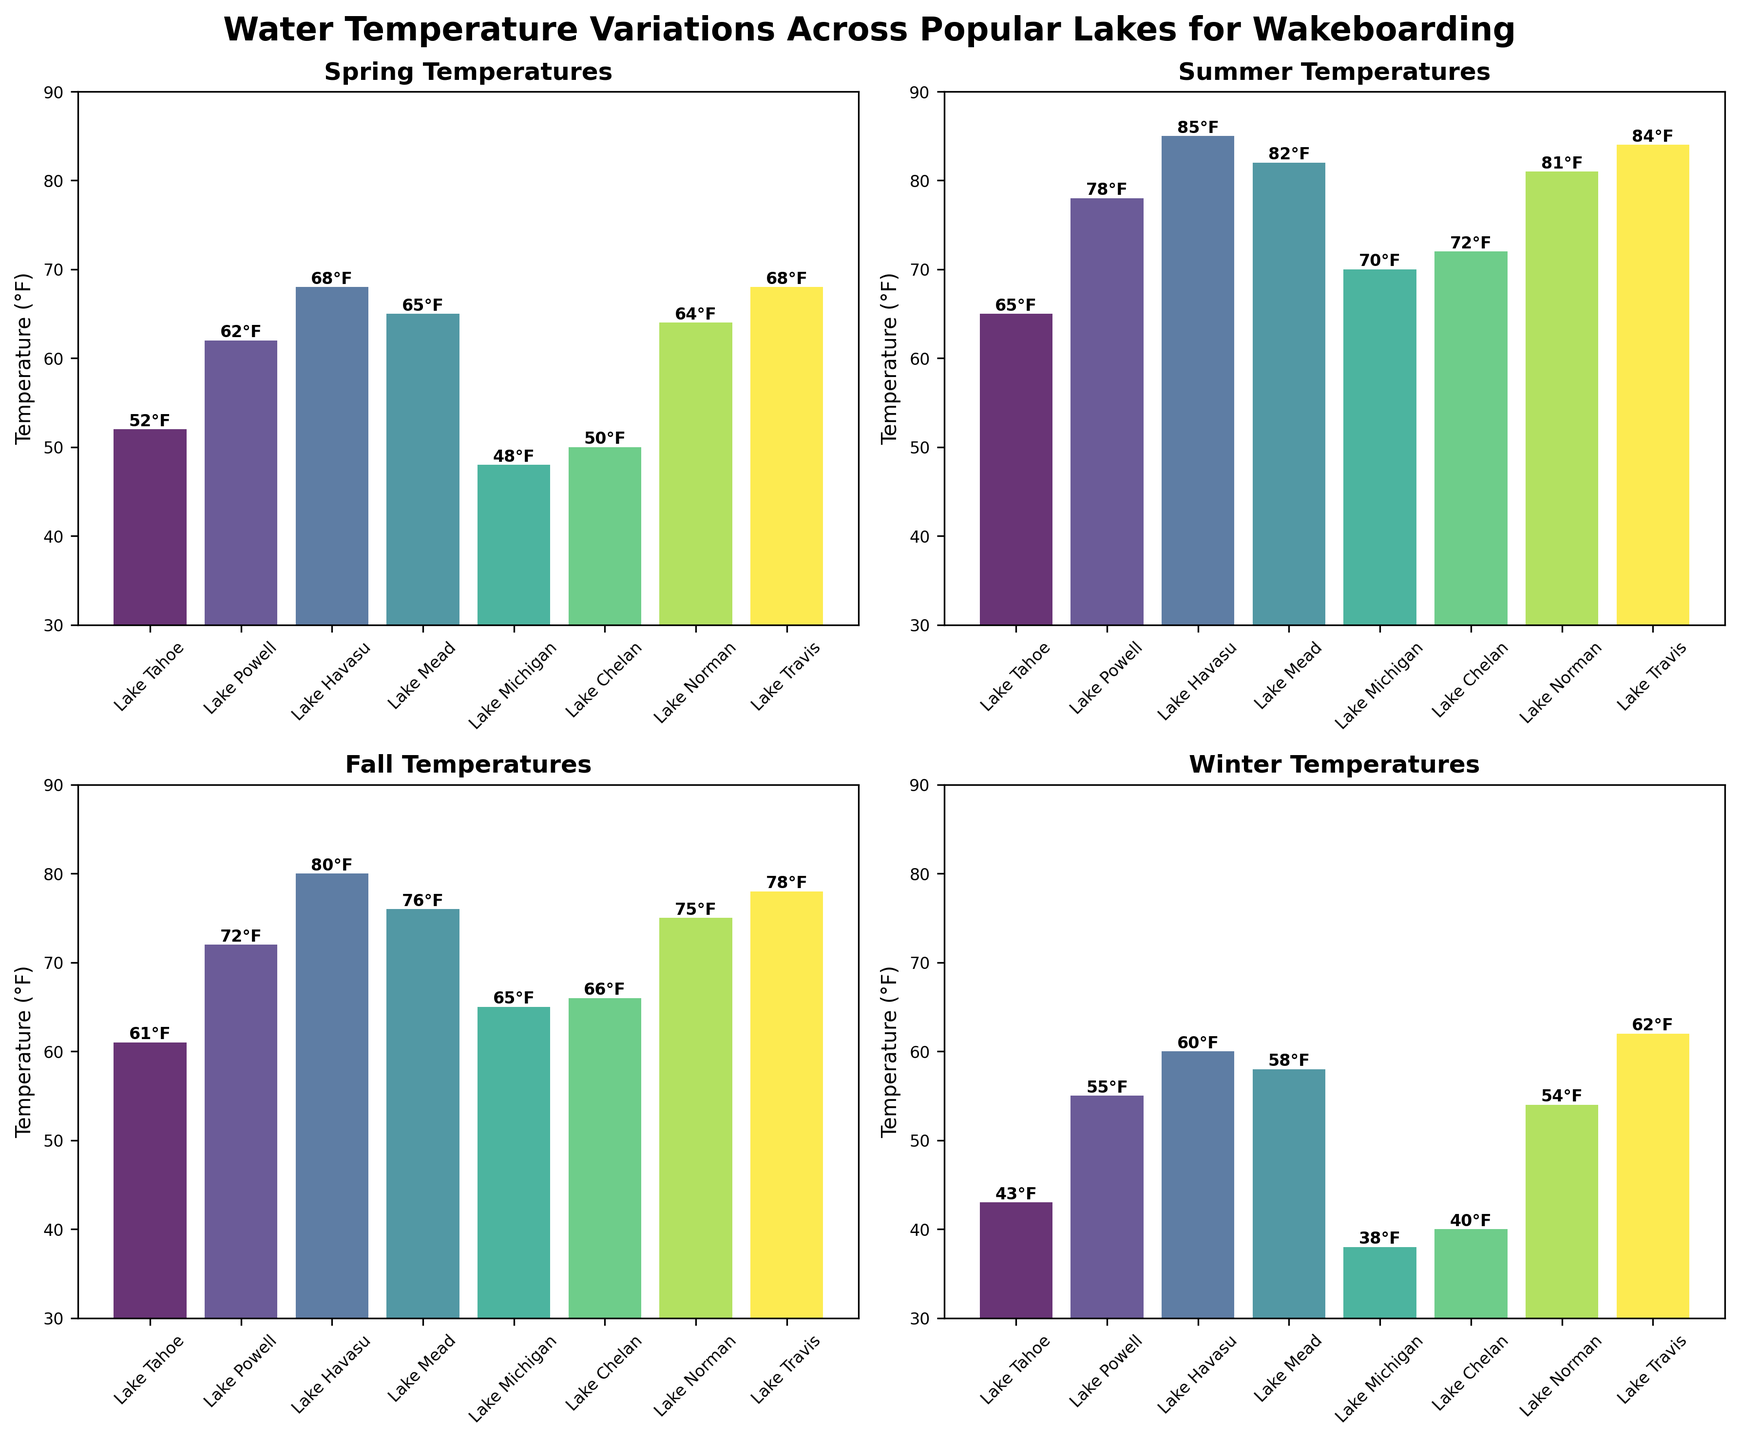Which lake has the highest water temperature in Summer? In the Summer subplot, look at the bars and the temperatures denoted on top of each bar. Lake Havasu has the highest temperature, marked at 85°F.
Answer: Lake Havasu How does the water temperature in Lake Tahoe vary across the four seasons? Read the temperatures for Lake Tahoe from each subplot: Spring, Summer, Fall, and Winter. They are 52°F, 65°F, 61°F, and 43°F respectively.
Answer: Spring: 52°F, Summer: 65°F, Fall: 61°F, Winter: 43°F Which season shows the greatest variation in water temperatures across the lakes? Compare the ranges of temperatures in each season's subplot by subtracting the lowest temperature from the highest. Winter ranges from 38°F to 62°F (24°F range), Spring from 48°F to 68°F (20°F range), Summer from 65°F to 85°F (20°F range), and Fall from 61°F to 80°F (19°F range).
Answer: Winter What's the average water temperature of Lake Michigan across all seasons? Add Lake Michigan's temperatures from each subplot (48°F, 70°F, 65°F, 38°F) and divide by 4. The calculation is (48 + 70 + 65 + 38) / 4.
Answer: 55.25°F Compared to Lake Powell in Winter, how much warmer is Lake Travis in Winter? Look at the Winter subplot and subtract Lake Powell's temperature (55°F) from Lake Travis's temperature (62°F). The difference is 62°F - 55°F.
Answer: 7°F Which lake has the smallest change in temperature from Summer to Fall? For each lake, subtract the Fall temperature from the Summer temperature. The smallest difference is for Lake Michigan, as 65°F - 70°F = -5°F, meaning a decrease of 5°F.
Answer: Lake Michigan What is the overall trend in water temperature from Spring to Winter for Lake Norman? Look at the subplots for each season and determine the progression of temperatures for Lake Norman: Spring 64°F, Summer 81°F, Fall 75°F, Winter 54°F. This shows a rise from Spring to Summer, slightly cooler in Fall, and lowest in Winter.
Answer: Rise, cool, lowest Which season has the highest average temperature across all the lakes? Calculate the average temperature for each season by adding up all the lake temperatures in that season and dividing by the number of lakes (8), and compare. For Spring: (52+62+68+65+48+50+64+68)/8 = 59.625°F, Summer: (65+78+85+82+70+72+81+84)/8 = 77.125°F, Fall: (61+72+80+76+65+66+75+78)/8 = 71.625°F, Winter: (43+55+60+58+38+40+54+62)/8 = 51.25°F. Summer has the highest average.
Answer: Summer Which lake shows the most significant drop in temperature from Fall to Winter? Calculate the difference in temperatures from Fall to Winter for each lake. The biggest difference is seen for Lake Michigan, where it drops from 65°F to 38°F, which is a 27°F drop.
Answer: Lake Michigan 